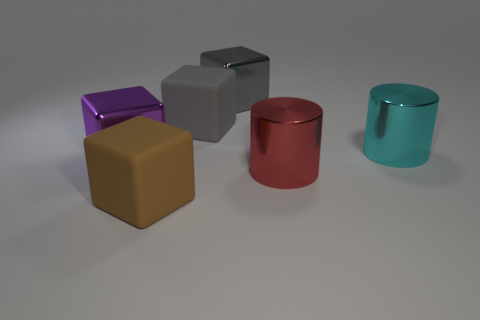Subtract all red cubes. Subtract all yellow cylinders. How many cubes are left? 4 Add 1 red shiny spheres. How many objects exist? 7 Subtract all blocks. How many objects are left? 2 Subtract all cubes. Subtract all cylinders. How many objects are left? 0 Add 4 gray cubes. How many gray cubes are left? 6 Add 6 metallic things. How many metallic things exist? 10 Subtract 1 red cylinders. How many objects are left? 5 